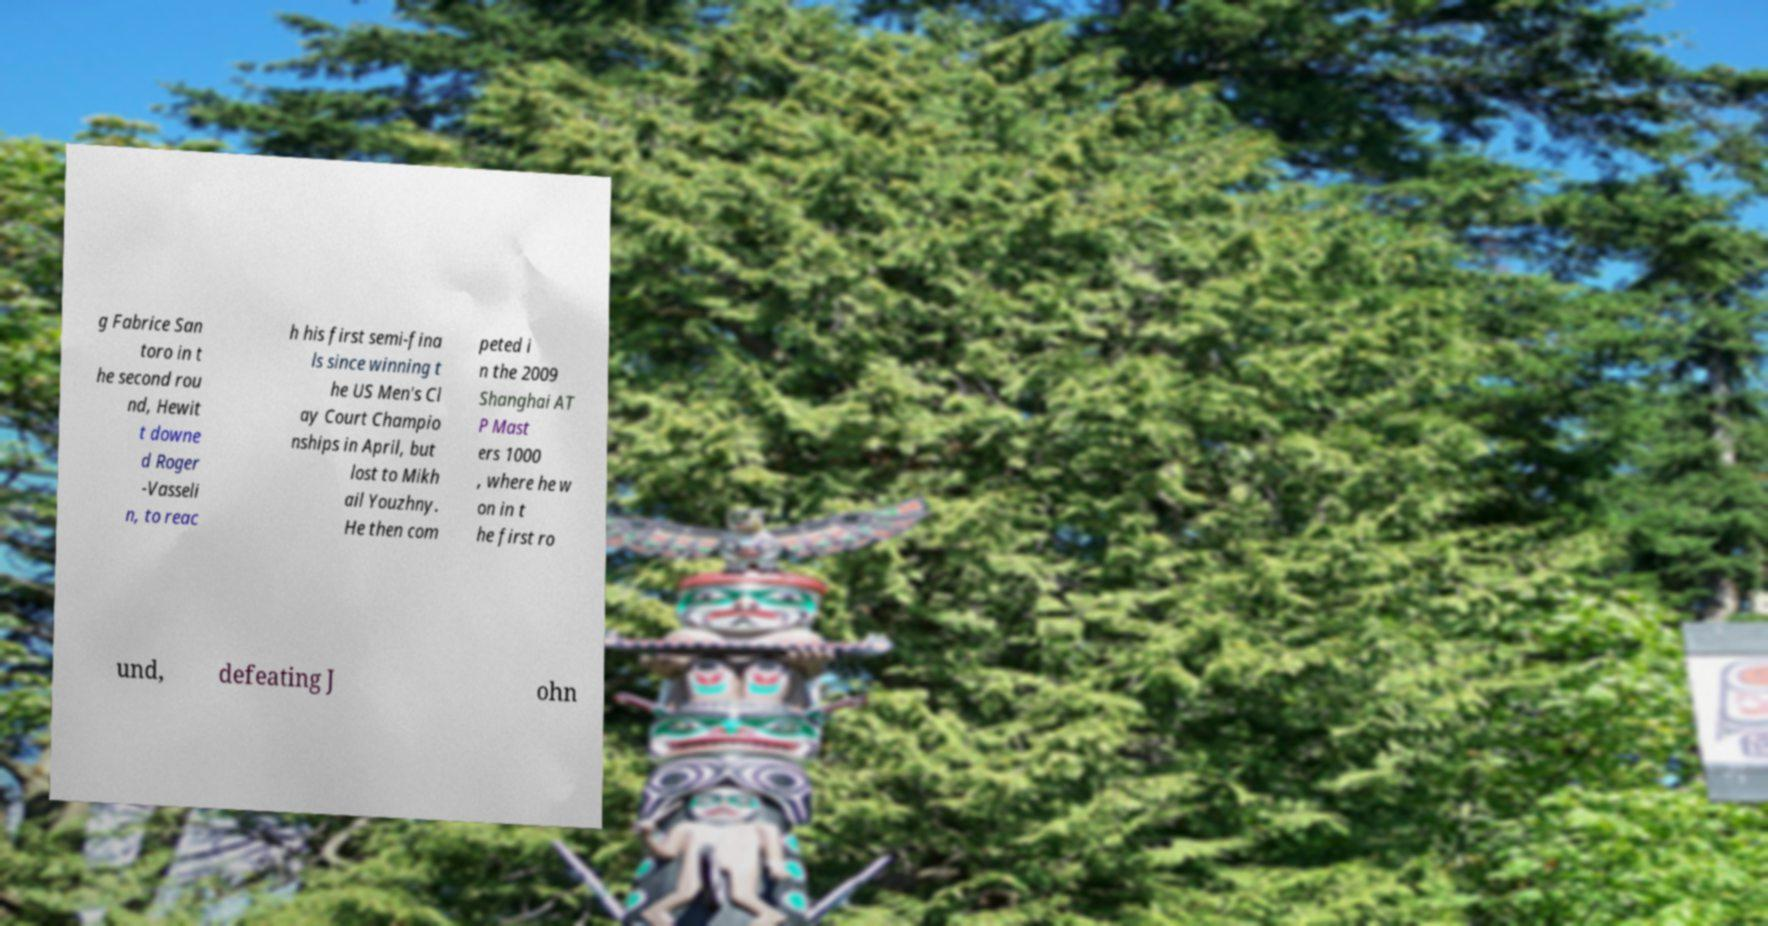Please identify and transcribe the text found in this image. g Fabrice San toro in t he second rou nd, Hewit t downe d Roger -Vasseli n, to reac h his first semi-fina ls since winning t he US Men's Cl ay Court Champio nships in April, but lost to Mikh ail Youzhny. He then com peted i n the 2009 Shanghai AT P Mast ers 1000 , where he w on in t he first ro und, defeating J ohn 